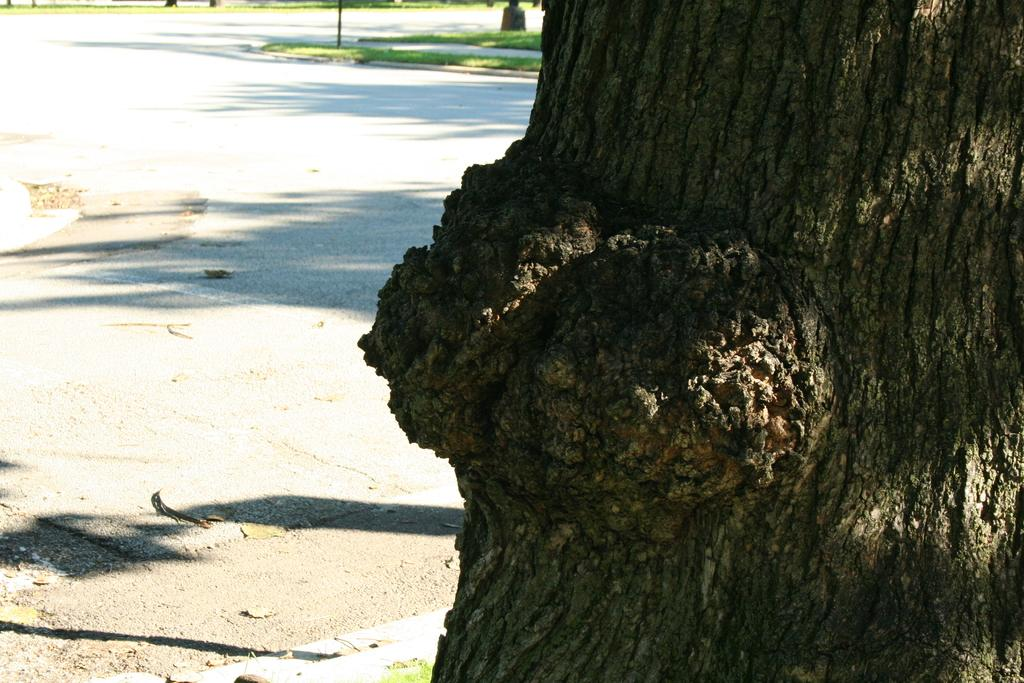What is the main subject in the foreground of the image? There is a tree trunk in the foreground of the image. What can be seen in the background of the image? There is a road and grass in the background of the image. How many trucks are participating in the competition in the image? There are no trucks or competition present in the image. Are there any horses visible in the image? There are no horses present in the image. 